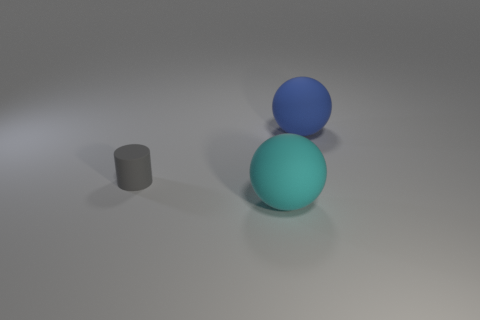Add 3 cyan rubber things. How many objects exist? 6 Add 3 cyan rubber balls. How many cyan rubber balls are left? 4 Add 1 small gray cylinders. How many small gray cylinders exist? 2 Subtract 0 purple cylinders. How many objects are left? 3 Subtract all cylinders. How many objects are left? 2 Subtract all large green matte things. Subtract all gray matte things. How many objects are left? 2 